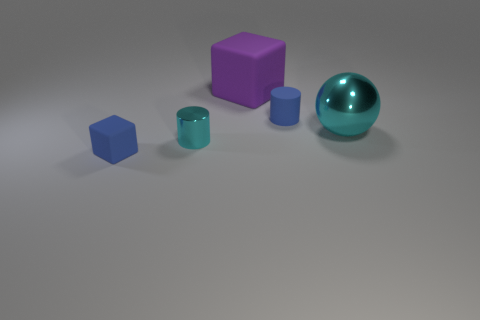Subtract all yellow cubes. Subtract all yellow balls. How many cubes are left? 2 Add 4 cyan objects. How many objects exist? 9 Subtract all cylinders. How many objects are left? 3 Subtract 1 cyan balls. How many objects are left? 4 Subtract all tiny yellow cubes. Subtract all shiny objects. How many objects are left? 3 Add 1 cubes. How many cubes are left? 3 Add 2 blue rubber blocks. How many blue rubber blocks exist? 3 